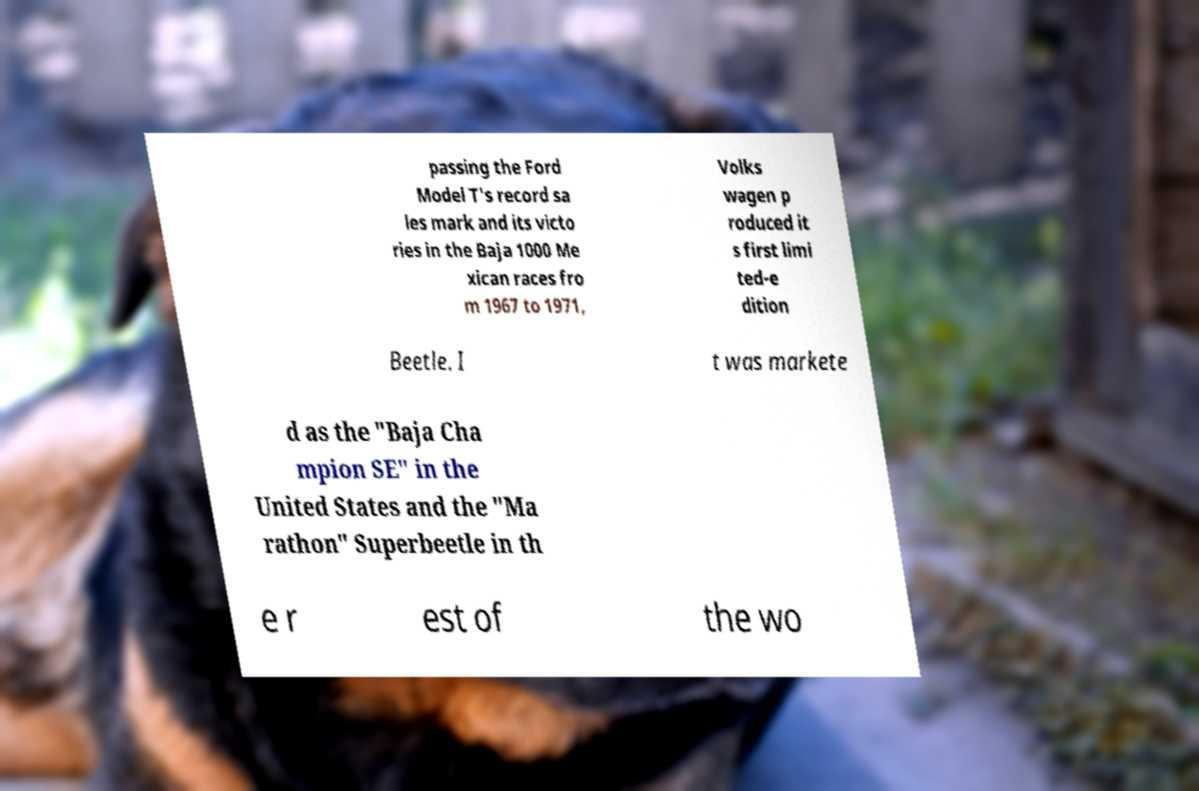What messages or text are displayed in this image? I need them in a readable, typed format. passing the Ford Model T's record sa les mark and its victo ries in the Baja 1000 Me xican races fro m 1967 to 1971, Volks wagen p roduced it s first limi ted-e dition Beetle. I t was markete d as the "Baja Cha mpion SE" in the United States and the "Ma rathon" Superbeetle in th e r est of the wo 